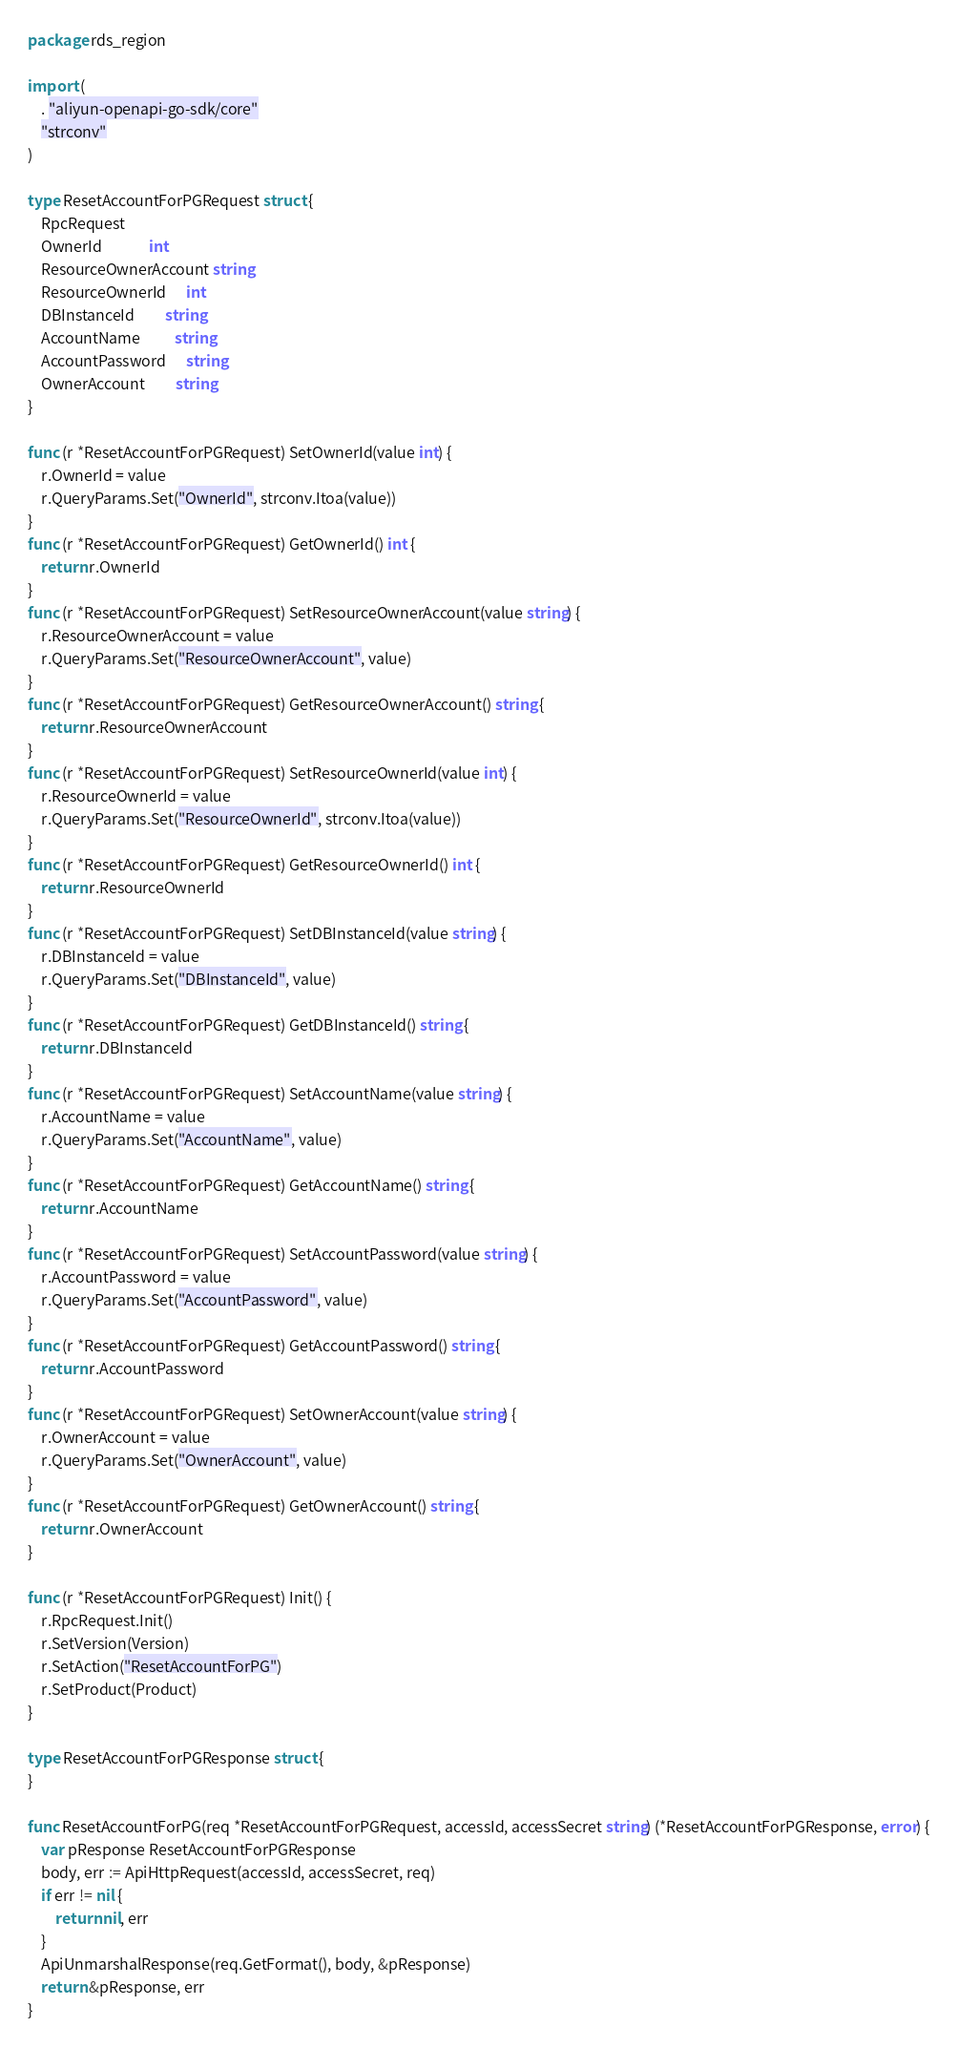<code> <loc_0><loc_0><loc_500><loc_500><_Go_>package rds_region

import (
	. "aliyun-openapi-go-sdk/core"
	"strconv"
)

type ResetAccountForPGRequest struct {
	RpcRequest
	OwnerId              int
	ResourceOwnerAccount string
	ResourceOwnerId      int
	DBInstanceId         string
	AccountName          string
	AccountPassword      string
	OwnerAccount         string
}

func (r *ResetAccountForPGRequest) SetOwnerId(value int) {
	r.OwnerId = value
	r.QueryParams.Set("OwnerId", strconv.Itoa(value))
}
func (r *ResetAccountForPGRequest) GetOwnerId() int {
	return r.OwnerId
}
func (r *ResetAccountForPGRequest) SetResourceOwnerAccount(value string) {
	r.ResourceOwnerAccount = value
	r.QueryParams.Set("ResourceOwnerAccount", value)
}
func (r *ResetAccountForPGRequest) GetResourceOwnerAccount() string {
	return r.ResourceOwnerAccount
}
func (r *ResetAccountForPGRequest) SetResourceOwnerId(value int) {
	r.ResourceOwnerId = value
	r.QueryParams.Set("ResourceOwnerId", strconv.Itoa(value))
}
func (r *ResetAccountForPGRequest) GetResourceOwnerId() int {
	return r.ResourceOwnerId
}
func (r *ResetAccountForPGRequest) SetDBInstanceId(value string) {
	r.DBInstanceId = value
	r.QueryParams.Set("DBInstanceId", value)
}
func (r *ResetAccountForPGRequest) GetDBInstanceId() string {
	return r.DBInstanceId
}
func (r *ResetAccountForPGRequest) SetAccountName(value string) {
	r.AccountName = value
	r.QueryParams.Set("AccountName", value)
}
func (r *ResetAccountForPGRequest) GetAccountName() string {
	return r.AccountName
}
func (r *ResetAccountForPGRequest) SetAccountPassword(value string) {
	r.AccountPassword = value
	r.QueryParams.Set("AccountPassword", value)
}
func (r *ResetAccountForPGRequest) GetAccountPassword() string {
	return r.AccountPassword
}
func (r *ResetAccountForPGRequest) SetOwnerAccount(value string) {
	r.OwnerAccount = value
	r.QueryParams.Set("OwnerAccount", value)
}
func (r *ResetAccountForPGRequest) GetOwnerAccount() string {
	return r.OwnerAccount
}

func (r *ResetAccountForPGRequest) Init() {
	r.RpcRequest.Init()
	r.SetVersion(Version)
	r.SetAction("ResetAccountForPG")
	r.SetProduct(Product)
}

type ResetAccountForPGResponse struct {
}

func ResetAccountForPG(req *ResetAccountForPGRequest, accessId, accessSecret string) (*ResetAccountForPGResponse, error) {
	var pResponse ResetAccountForPGResponse
	body, err := ApiHttpRequest(accessId, accessSecret, req)
	if err != nil {
		return nil, err
	}
	ApiUnmarshalResponse(req.GetFormat(), body, &pResponse)
	return &pResponse, err
}
</code> 